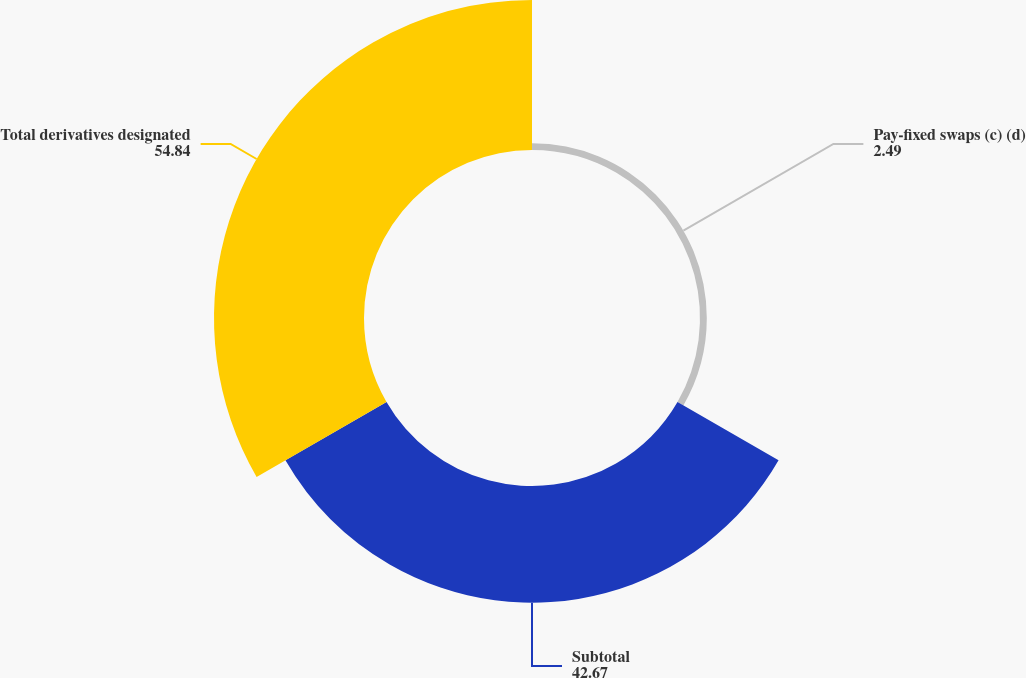Convert chart to OTSL. <chart><loc_0><loc_0><loc_500><loc_500><pie_chart><fcel>Pay-fixed swaps (c) (d)<fcel>Subtotal<fcel>Total derivatives designated<nl><fcel>2.49%<fcel>42.67%<fcel>54.84%<nl></chart> 